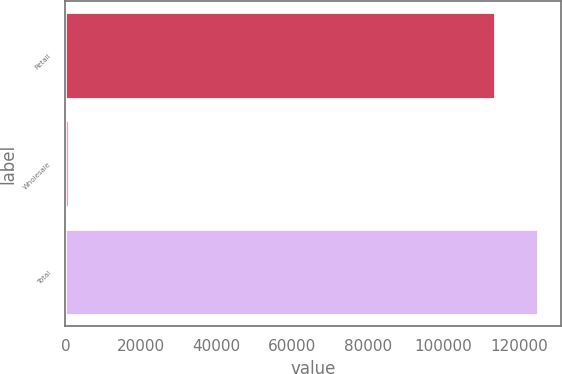Convert chart to OTSL. <chart><loc_0><loc_0><loc_500><loc_500><bar_chart><fcel>Retail<fcel>Wholesale<fcel>Total<nl><fcel>113604<fcel>984<fcel>124964<nl></chart> 